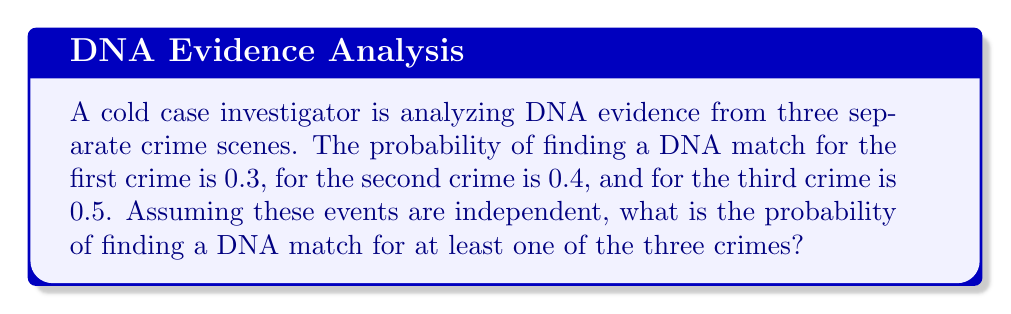Solve this math problem. Let's approach this step-by-step using the concept of complementary events and the multiplication rule for independent events:

1) Let's define our events:
   A: DNA match for the first crime
   B: DNA match for the second crime
   C: DNA match for the third crime

2) We're looking for P(at least one match) = 1 - P(no matches)

3) P(no matches) = P(no match for A AND no match for B AND no match for C)

4) Since the events are independent:
   P(no matches) = P(no A) × P(no B) × P(no C)

5) We can calculate the probability of no match for each crime:
   P(no A) = 1 - P(A) = 1 - 0.3 = 0.7
   P(no B) = 1 - P(B) = 1 - 0.4 = 0.6
   P(no C) = 1 - P(C) = 1 - 0.5 = 0.5

6) Now we can calculate:
   P(no matches) = 0.7 × 0.6 × 0.5 = 0.21

7) Therefore:
   P(at least one match) = 1 - P(no matches)
                         = 1 - 0.21
                         = 0.79

So, the probability of finding a DNA match for at least one of the three crimes is 0.79 or 79%.
Answer: $0.79$ 